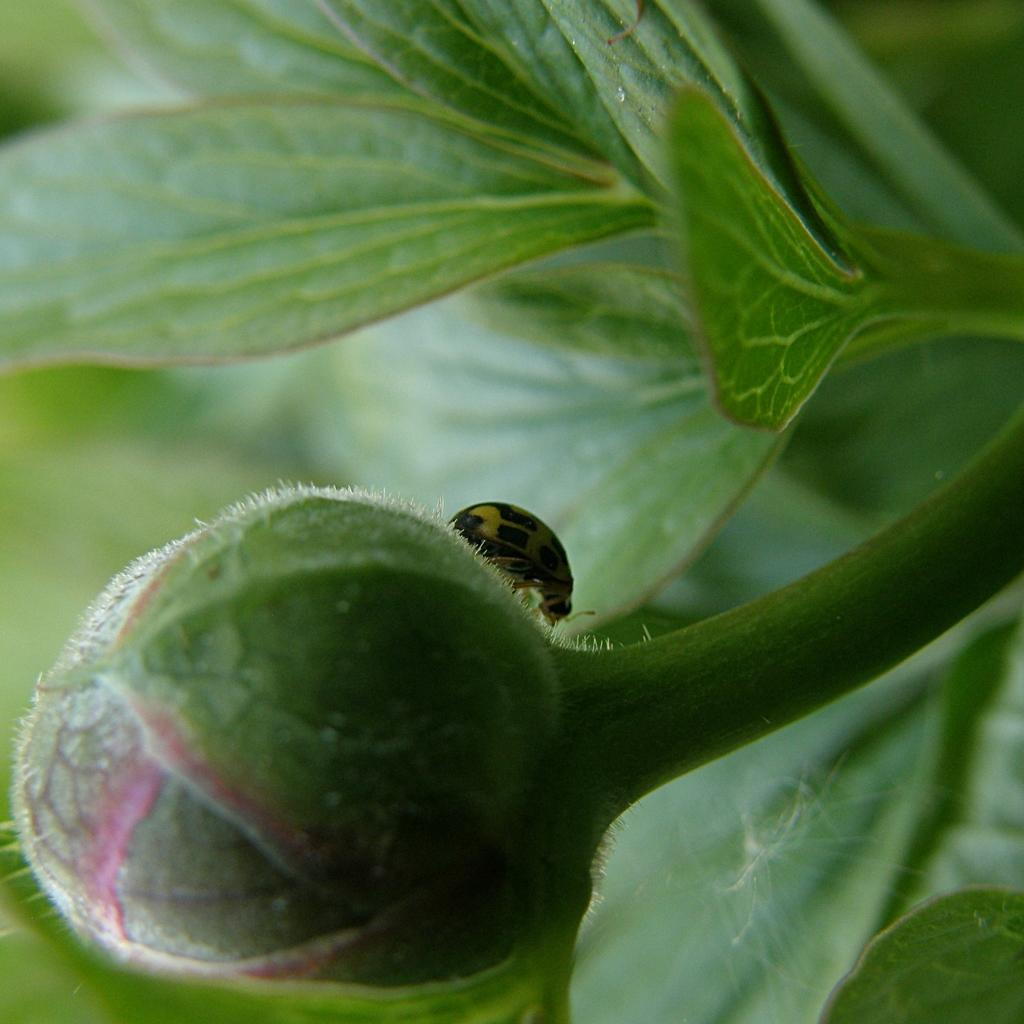What is present on the plant in the image? There is a flower bud on a plant. Is there anything else on the flower bud? Yes, there is a bug on the flower bud. How does the board compare to the lawyer in the image? There is no board or lawyer present in the image; it only features a flower bud and a bug. 